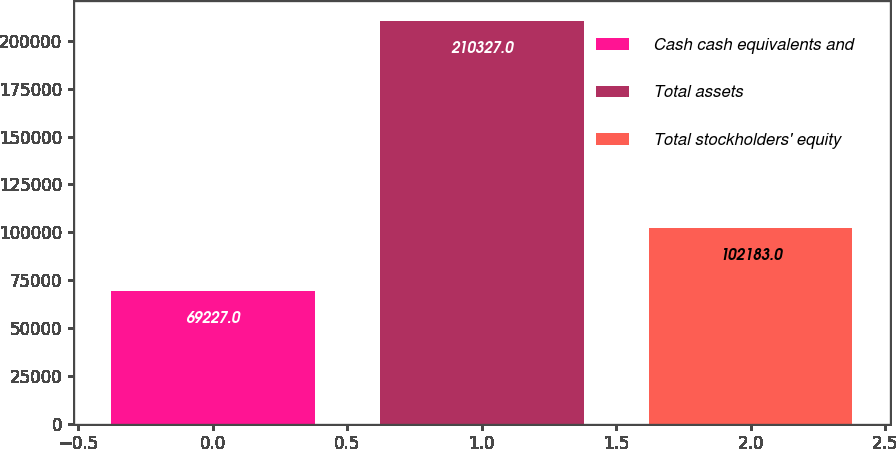Convert chart to OTSL. <chart><loc_0><loc_0><loc_500><loc_500><bar_chart><fcel>Cash cash equivalents and<fcel>Total assets<fcel>Total stockholders' equity<nl><fcel>69227<fcel>210327<fcel>102183<nl></chart> 